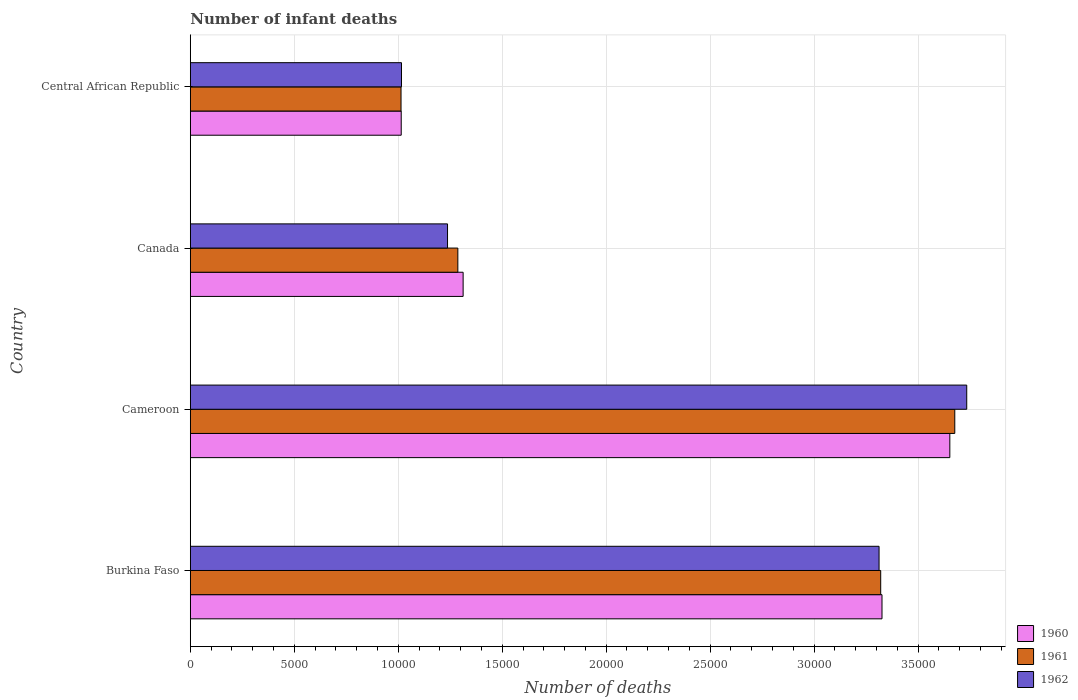How many different coloured bars are there?
Offer a terse response. 3. Are the number of bars on each tick of the Y-axis equal?
Keep it short and to the point. Yes. How many bars are there on the 4th tick from the bottom?
Offer a terse response. 3. What is the label of the 2nd group of bars from the top?
Your answer should be very brief. Canada. In how many cases, is the number of bars for a given country not equal to the number of legend labels?
Make the answer very short. 0. What is the number of infant deaths in 1961 in Burkina Faso?
Provide a succinct answer. 3.32e+04. Across all countries, what is the maximum number of infant deaths in 1961?
Ensure brevity in your answer.  3.68e+04. Across all countries, what is the minimum number of infant deaths in 1960?
Make the answer very short. 1.01e+04. In which country was the number of infant deaths in 1960 maximum?
Ensure brevity in your answer.  Cameroon. In which country was the number of infant deaths in 1961 minimum?
Provide a short and direct response. Central African Republic. What is the total number of infant deaths in 1960 in the graph?
Provide a succinct answer. 9.31e+04. What is the difference between the number of infant deaths in 1962 in Cameroon and that in Central African Republic?
Make the answer very short. 2.72e+04. What is the difference between the number of infant deaths in 1962 in Central African Republic and the number of infant deaths in 1961 in Canada?
Provide a succinct answer. -2710. What is the average number of infant deaths in 1961 per country?
Keep it short and to the point. 2.32e+04. What is the difference between the number of infant deaths in 1961 and number of infant deaths in 1960 in Cameroon?
Your answer should be compact. 238. In how many countries, is the number of infant deaths in 1961 greater than 37000 ?
Offer a terse response. 0. What is the ratio of the number of infant deaths in 1961 in Canada to that in Central African Republic?
Give a very brief answer. 1.27. What is the difference between the highest and the second highest number of infant deaths in 1960?
Provide a succinct answer. 3262. What is the difference between the highest and the lowest number of infant deaths in 1962?
Give a very brief answer. 2.72e+04. In how many countries, is the number of infant deaths in 1961 greater than the average number of infant deaths in 1961 taken over all countries?
Your response must be concise. 2. Is the sum of the number of infant deaths in 1961 in Cameroon and Central African Republic greater than the maximum number of infant deaths in 1960 across all countries?
Give a very brief answer. Yes. What does the 1st bar from the top in Burkina Faso represents?
Keep it short and to the point. 1962. What does the 1st bar from the bottom in Central African Republic represents?
Your response must be concise. 1960. Are all the bars in the graph horizontal?
Offer a very short reply. Yes. How many countries are there in the graph?
Your answer should be compact. 4. What is the difference between two consecutive major ticks on the X-axis?
Offer a very short reply. 5000. Where does the legend appear in the graph?
Your answer should be compact. Bottom right. How many legend labels are there?
Ensure brevity in your answer.  3. How are the legend labels stacked?
Make the answer very short. Vertical. What is the title of the graph?
Provide a succinct answer. Number of infant deaths. What is the label or title of the X-axis?
Offer a very short reply. Number of deaths. What is the Number of deaths in 1960 in Burkina Faso?
Ensure brevity in your answer.  3.33e+04. What is the Number of deaths in 1961 in Burkina Faso?
Offer a terse response. 3.32e+04. What is the Number of deaths in 1962 in Burkina Faso?
Keep it short and to the point. 3.31e+04. What is the Number of deaths of 1960 in Cameroon?
Provide a short and direct response. 3.65e+04. What is the Number of deaths of 1961 in Cameroon?
Your answer should be compact. 3.68e+04. What is the Number of deaths of 1962 in Cameroon?
Provide a succinct answer. 3.73e+04. What is the Number of deaths in 1960 in Canada?
Keep it short and to the point. 1.31e+04. What is the Number of deaths of 1961 in Canada?
Give a very brief answer. 1.29e+04. What is the Number of deaths of 1962 in Canada?
Provide a succinct answer. 1.24e+04. What is the Number of deaths of 1960 in Central African Republic?
Ensure brevity in your answer.  1.01e+04. What is the Number of deaths of 1961 in Central African Republic?
Give a very brief answer. 1.01e+04. What is the Number of deaths in 1962 in Central African Republic?
Ensure brevity in your answer.  1.02e+04. Across all countries, what is the maximum Number of deaths of 1960?
Provide a succinct answer. 3.65e+04. Across all countries, what is the maximum Number of deaths in 1961?
Keep it short and to the point. 3.68e+04. Across all countries, what is the maximum Number of deaths of 1962?
Your answer should be very brief. 3.73e+04. Across all countries, what is the minimum Number of deaths in 1960?
Keep it short and to the point. 1.01e+04. Across all countries, what is the minimum Number of deaths of 1961?
Make the answer very short. 1.01e+04. Across all countries, what is the minimum Number of deaths in 1962?
Your answer should be compact. 1.02e+04. What is the total Number of deaths in 1960 in the graph?
Give a very brief answer. 9.31e+04. What is the total Number of deaths of 1961 in the graph?
Offer a very short reply. 9.30e+04. What is the total Number of deaths of 1962 in the graph?
Make the answer very short. 9.30e+04. What is the difference between the Number of deaths in 1960 in Burkina Faso and that in Cameroon?
Your answer should be very brief. -3262. What is the difference between the Number of deaths in 1961 in Burkina Faso and that in Cameroon?
Offer a very short reply. -3562. What is the difference between the Number of deaths in 1962 in Burkina Faso and that in Cameroon?
Your answer should be very brief. -4216. What is the difference between the Number of deaths in 1960 in Burkina Faso and that in Canada?
Ensure brevity in your answer.  2.01e+04. What is the difference between the Number of deaths of 1961 in Burkina Faso and that in Canada?
Your response must be concise. 2.03e+04. What is the difference between the Number of deaths in 1962 in Burkina Faso and that in Canada?
Offer a very short reply. 2.08e+04. What is the difference between the Number of deaths of 1960 in Burkina Faso and that in Central African Republic?
Provide a short and direct response. 2.31e+04. What is the difference between the Number of deaths of 1961 in Burkina Faso and that in Central African Republic?
Your answer should be compact. 2.31e+04. What is the difference between the Number of deaths of 1962 in Burkina Faso and that in Central African Republic?
Provide a succinct answer. 2.30e+04. What is the difference between the Number of deaths of 1960 in Cameroon and that in Canada?
Keep it short and to the point. 2.34e+04. What is the difference between the Number of deaths in 1961 in Cameroon and that in Canada?
Your response must be concise. 2.39e+04. What is the difference between the Number of deaths of 1962 in Cameroon and that in Canada?
Your response must be concise. 2.50e+04. What is the difference between the Number of deaths in 1960 in Cameroon and that in Central African Republic?
Make the answer very short. 2.64e+04. What is the difference between the Number of deaths in 1961 in Cameroon and that in Central African Republic?
Your response must be concise. 2.66e+04. What is the difference between the Number of deaths in 1962 in Cameroon and that in Central African Republic?
Keep it short and to the point. 2.72e+04. What is the difference between the Number of deaths in 1960 in Canada and that in Central African Republic?
Keep it short and to the point. 2977. What is the difference between the Number of deaths in 1961 in Canada and that in Central African Republic?
Your answer should be very brief. 2732. What is the difference between the Number of deaths in 1962 in Canada and that in Central African Republic?
Your response must be concise. 2214. What is the difference between the Number of deaths in 1960 in Burkina Faso and the Number of deaths in 1961 in Cameroon?
Ensure brevity in your answer.  -3500. What is the difference between the Number of deaths of 1960 in Burkina Faso and the Number of deaths of 1962 in Cameroon?
Provide a short and direct response. -4075. What is the difference between the Number of deaths of 1961 in Burkina Faso and the Number of deaths of 1962 in Cameroon?
Offer a very short reply. -4137. What is the difference between the Number of deaths in 1960 in Burkina Faso and the Number of deaths in 1961 in Canada?
Offer a terse response. 2.04e+04. What is the difference between the Number of deaths in 1960 in Burkina Faso and the Number of deaths in 1962 in Canada?
Ensure brevity in your answer.  2.09e+04. What is the difference between the Number of deaths of 1961 in Burkina Faso and the Number of deaths of 1962 in Canada?
Your response must be concise. 2.08e+04. What is the difference between the Number of deaths of 1960 in Burkina Faso and the Number of deaths of 1961 in Central African Republic?
Make the answer very short. 2.31e+04. What is the difference between the Number of deaths in 1960 in Burkina Faso and the Number of deaths in 1962 in Central African Republic?
Provide a succinct answer. 2.31e+04. What is the difference between the Number of deaths of 1961 in Burkina Faso and the Number of deaths of 1962 in Central African Republic?
Offer a terse response. 2.30e+04. What is the difference between the Number of deaths of 1960 in Cameroon and the Number of deaths of 1961 in Canada?
Your response must be concise. 2.37e+04. What is the difference between the Number of deaths in 1960 in Cameroon and the Number of deaths in 1962 in Canada?
Give a very brief answer. 2.42e+04. What is the difference between the Number of deaths in 1961 in Cameroon and the Number of deaths in 1962 in Canada?
Your answer should be very brief. 2.44e+04. What is the difference between the Number of deaths of 1960 in Cameroon and the Number of deaths of 1961 in Central African Republic?
Offer a terse response. 2.64e+04. What is the difference between the Number of deaths of 1960 in Cameroon and the Number of deaths of 1962 in Central African Republic?
Your response must be concise. 2.64e+04. What is the difference between the Number of deaths in 1961 in Cameroon and the Number of deaths in 1962 in Central African Republic?
Your answer should be very brief. 2.66e+04. What is the difference between the Number of deaths of 1960 in Canada and the Number of deaths of 1961 in Central African Republic?
Offer a very short reply. 2986. What is the difference between the Number of deaths of 1960 in Canada and the Number of deaths of 1962 in Central African Republic?
Ensure brevity in your answer.  2964. What is the difference between the Number of deaths in 1961 in Canada and the Number of deaths in 1962 in Central African Republic?
Ensure brevity in your answer.  2710. What is the average Number of deaths of 1960 per country?
Provide a short and direct response. 2.33e+04. What is the average Number of deaths of 1961 per country?
Your response must be concise. 2.32e+04. What is the average Number of deaths of 1962 per country?
Offer a terse response. 2.32e+04. What is the difference between the Number of deaths of 1960 and Number of deaths of 1961 in Burkina Faso?
Make the answer very short. 62. What is the difference between the Number of deaths of 1960 and Number of deaths of 1962 in Burkina Faso?
Provide a short and direct response. 141. What is the difference between the Number of deaths in 1961 and Number of deaths in 1962 in Burkina Faso?
Offer a very short reply. 79. What is the difference between the Number of deaths in 1960 and Number of deaths in 1961 in Cameroon?
Your answer should be compact. -238. What is the difference between the Number of deaths of 1960 and Number of deaths of 1962 in Cameroon?
Give a very brief answer. -813. What is the difference between the Number of deaths of 1961 and Number of deaths of 1962 in Cameroon?
Your response must be concise. -575. What is the difference between the Number of deaths in 1960 and Number of deaths in 1961 in Canada?
Provide a short and direct response. 254. What is the difference between the Number of deaths of 1960 and Number of deaths of 1962 in Canada?
Provide a short and direct response. 750. What is the difference between the Number of deaths of 1961 and Number of deaths of 1962 in Canada?
Your answer should be very brief. 496. What is the difference between the Number of deaths of 1960 and Number of deaths of 1961 in Central African Republic?
Provide a short and direct response. 9. What is the ratio of the Number of deaths of 1960 in Burkina Faso to that in Cameroon?
Provide a succinct answer. 0.91. What is the ratio of the Number of deaths of 1961 in Burkina Faso to that in Cameroon?
Give a very brief answer. 0.9. What is the ratio of the Number of deaths of 1962 in Burkina Faso to that in Cameroon?
Your answer should be compact. 0.89. What is the ratio of the Number of deaths of 1960 in Burkina Faso to that in Canada?
Offer a very short reply. 2.54. What is the ratio of the Number of deaths in 1961 in Burkina Faso to that in Canada?
Your answer should be very brief. 2.58. What is the ratio of the Number of deaths in 1962 in Burkina Faso to that in Canada?
Provide a succinct answer. 2.68. What is the ratio of the Number of deaths in 1960 in Burkina Faso to that in Central African Republic?
Offer a terse response. 3.28. What is the ratio of the Number of deaths of 1961 in Burkina Faso to that in Central African Republic?
Your answer should be compact. 3.28. What is the ratio of the Number of deaths of 1962 in Burkina Faso to that in Central African Republic?
Offer a very short reply. 3.26. What is the ratio of the Number of deaths in 1960 in Cameroon to that in Canada?
Make the answer very short. 2.78. What is the ratio of the Number of deaths in 1961 in Cameroon to that in Canada?
Offer a terse response. 2.86. What is the ratio of the Number of deaths in 1962 in Cameroon to that in Canada?
Give a very brief answer. 3.02. What is the ratio of the Number of deaths of 1960 in Cameroon to that in Central African Republic?
Give a very brief answer. 3.6. What is the ratio of the Number of deaths in 1961 in Cameroon to that in Central African Republic?
Give a very brief answer. 3.63. What is the ratio of the Number of deaths in 1962 in Cameroon to that in Central African Republic?
Your answer should be compact. 3.68. What is the ratio of the Number of deaths in 1960 in Canada to that in Central African Republic?
Your response must be concise. 1.29. What is the ratio of the Number of deaths of 1961 in Canada to that in Central African Republic?
Make the answer very short. 1.27. What is the ratio of the Number of deaths in 1962 in Canada to that in Central African Republic?
Give a very brief answer. 1.22. What is the difference between the highest and the second highest Number of deaths in 1960?
Ensure brevity in your answer.  3262. What is the difference between the highest and the second highest Number of deaths of 1961?
Make the answer very short. 3562. What is the difference between the highest and the second highest Number of deaths in 1962?
Make the answer very short. 4216. What is the difference between the highest and the lowest Number of deaths in 1960?
Provide a short and direct response. 2.64e+04. What is the difference between the highest and the lowest Number of deaths in 1961?
Keep it short and to the point. 2.66e+04. What is the difference between the highest and the lowest Number of deaths of 1962?
Provide a succinct answer. 2.72e+04. 